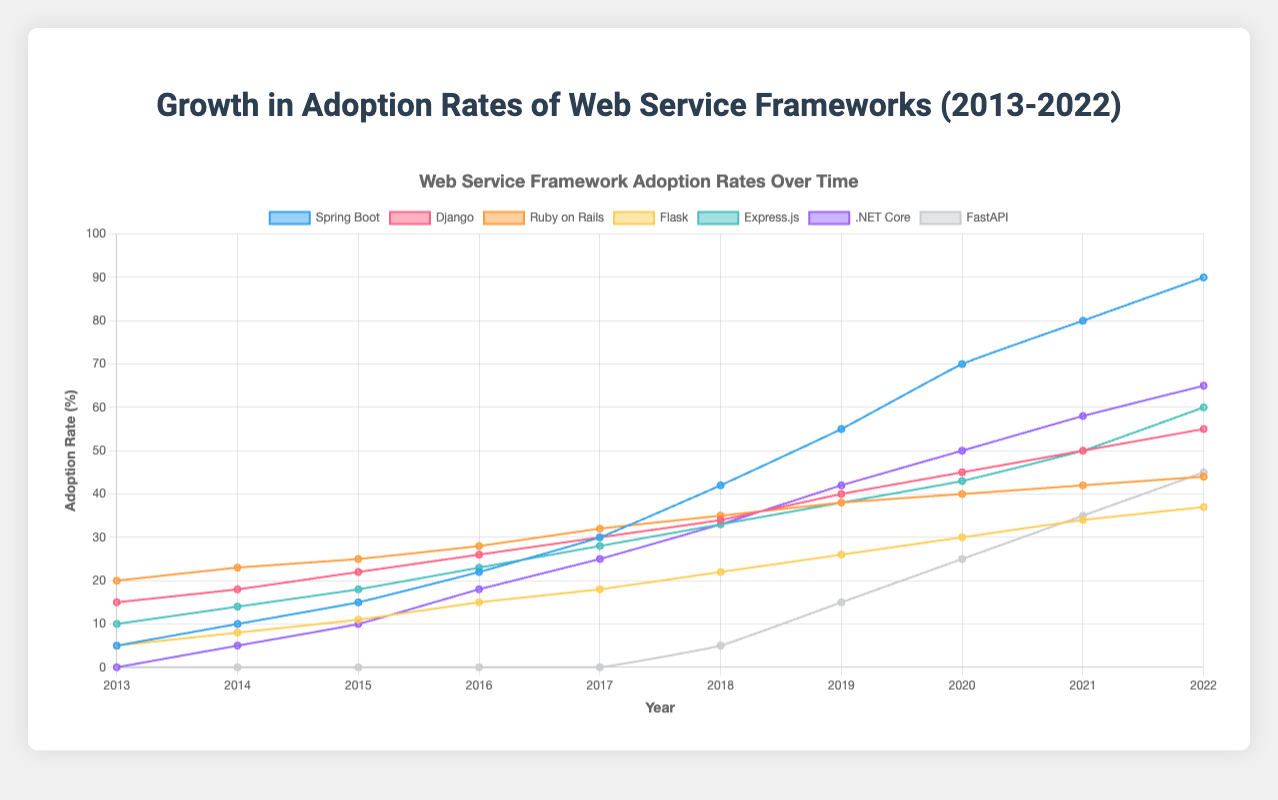Which web service framework shows the highest adoption rate in 2022? To determine which framework has the highest adoption rate in 2022, we look at the adoption rates for each framework in the year 2022. Spring Boot has the highest value at 90 percent.
Answer: Spring Boot Which framework experienced the largest growth in adoption rate from 2013 to 2022? We compare the difference in adoption rates from 2013 to 2022 for each framework. Spring Boot grew from 5 to 90, a growth of 85 percent, which is the largest.
Answer: Spring Boot How did Django's adoption rate in 2018 compare to Flask's in 2018? Django's adoption rate in 2018 was 34 percent, while Flask's was 22 percent. Therefore, Django's adoption rate was higher than Flask's in 2018.
Answer: Django was higher What is the average adoption rate of Express.js over the decade 2013-2022? Sum the adoption rates of Express.js from 2013 to 2022 and divide by the number of years (10): (10 + 14 + 18 + 23 + 28 + 33 + 38 + 43 + 50 + 60)/10 = 31.7 percent
Answer: 31.7 Which year did FastAPI start showing an adoption rate, and what was it? FastAPI started showing an adoption rate in 2018 with a value of 5 percent.
Answer: 2018, 5 percent Compare the growth rates of .NET Core and Flask from 2015 to 2020. Which one grew more rapidly? .NET Core's adoption rate grew from 10 in 2015 to 50 in 2020, an increase of 40. Flask’s rate grew from 11 to 30, an increase of 19. .NET Core had a more rapid growth.
Answer: .NET Core What is the trend of Ruby on Rails' adoption rate over the decade? Ruby on Rails' adoption rate shows a steady but slower growth compared to other frameworks, increasing gradually from 20 to 44 percent over the decade.
Answer: Steady, slow growth Which two frameworks had the same adoption rate in 2013, and what was that rate? Both Spring Boot and Flask had an adoption rate of 5 percent in 2013.
Answer: Spring Boot and Flask, 5 percent 